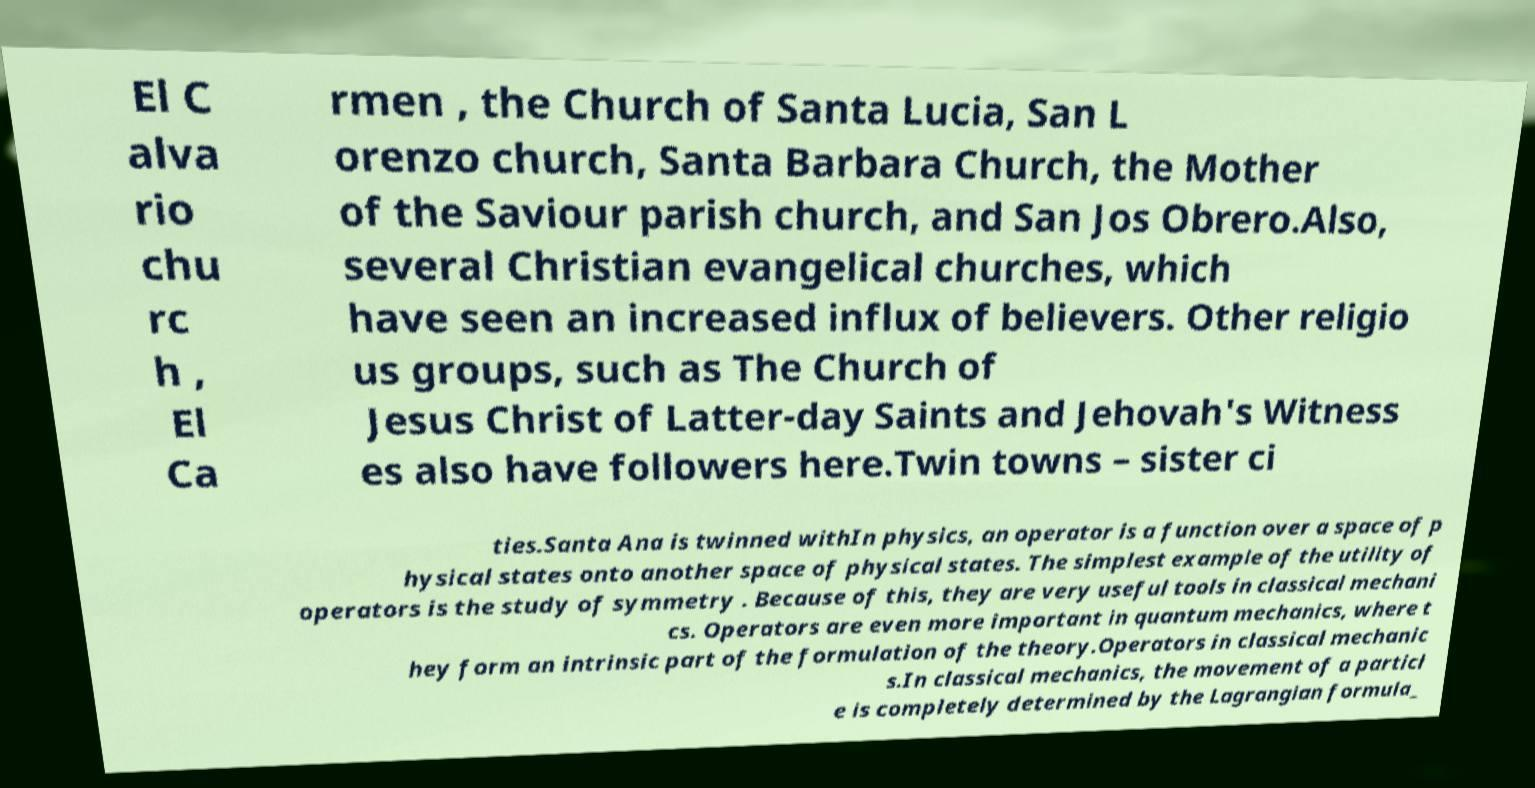I need the written content from this picture converted into text. Can you do that? El C alva rio chu rc h , El Ca rmen , the Church of Santa Lucia, San L orenzo church, Santa Barbara Church, the Mother of the Saviour parish church, and San Jos Obrero.Also, several Christian evangelical churches, which have seen an increased influx of believers. Other religio us groups, such as The Church of Jesus Christ of Latter-day Saints and Jehovah's Witness es also have followers here.Twin towns – sister ci ties.Santa Ana is twinned withIn physics, an operator is a function over a space of p hysical states onto another space of physical states. The simplest example of the utility of operators is the study of symmetry . Because of this, they are very useful tools in classical mechani cs. Operators are even more important in quantum mechanics, where t hey form an intrinsic part of the formulation of the theory.Operators in classical mechanic s.In classical mechanics, the movement of a particl e is completely determined by the Lagrangian formula_ 